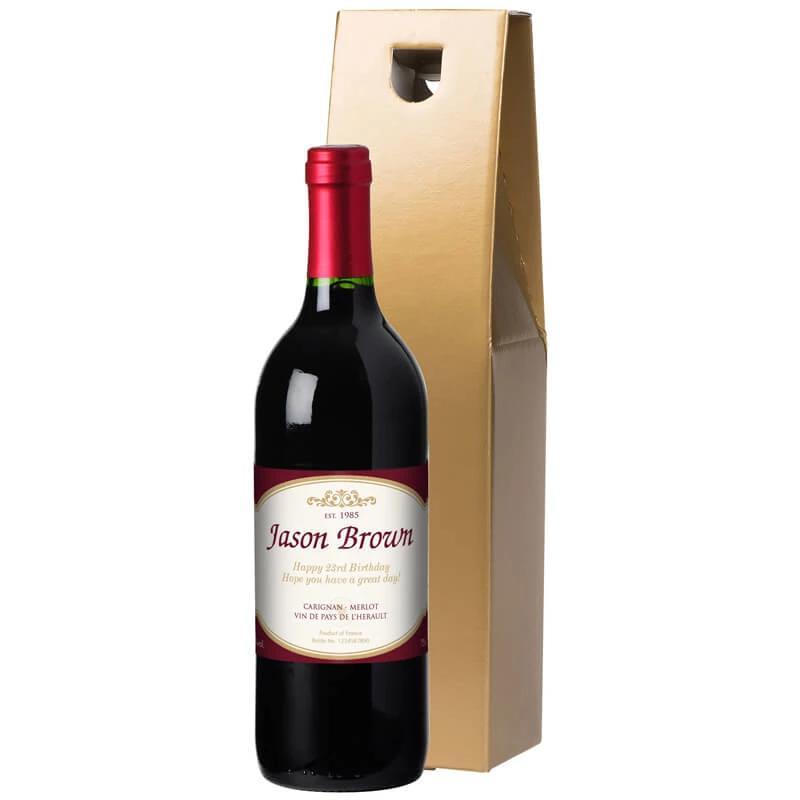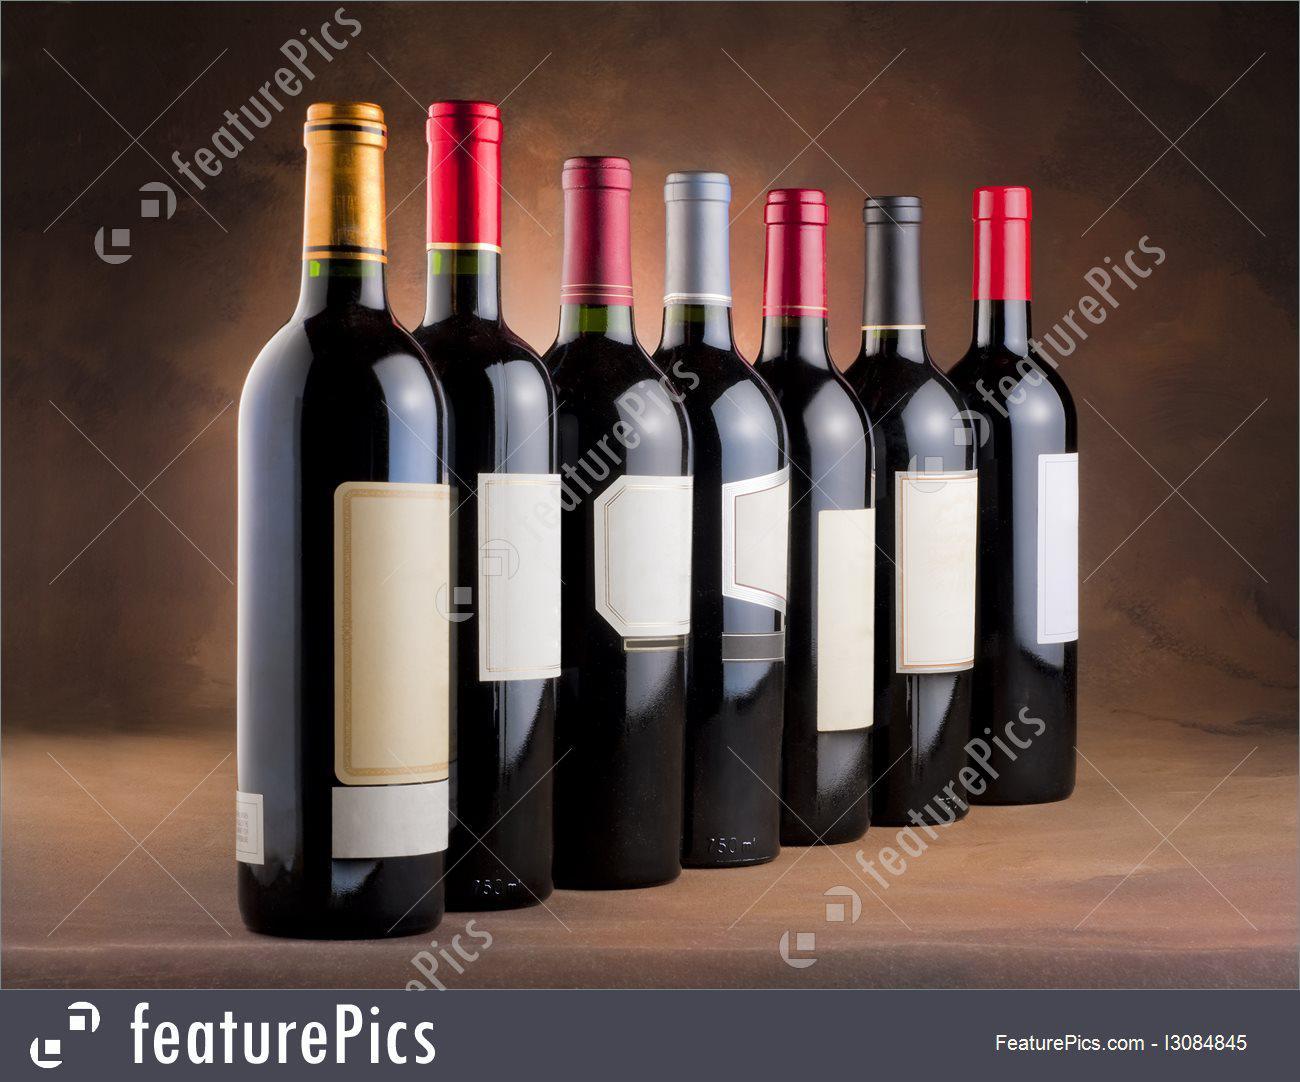The first image is the image on the left, the second image is the image on the right. Evaluate the accuracy of this statement regarding the images: "A single bottle of wine stands in the image on the left.". Is it true? Answer yes or no. Yes. The first image is the image on the left, the second image is the image on the right. For the images shown, is this caption "The left image includes two wine glasses." true? Answer yes or no. No. 